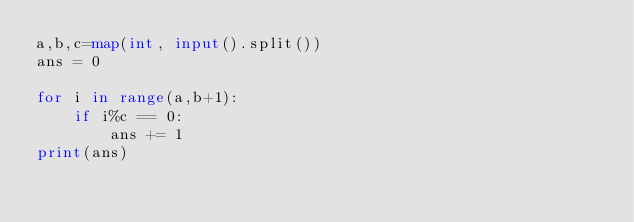Convert code to text. <code><loc_0><loc_0><loc_500><loc_500><_Python_>a,b,c=map(int, input().split()) 
ans = 0

for i in range(a,b+1):
    if i%c == 0:
        ans += 1
print(ans)</code> 